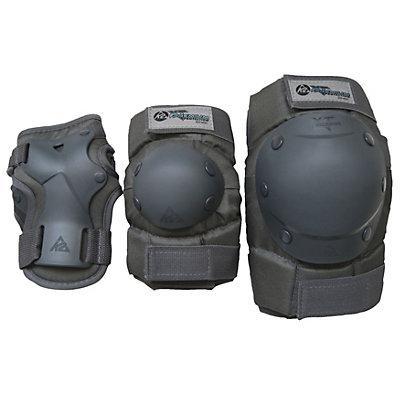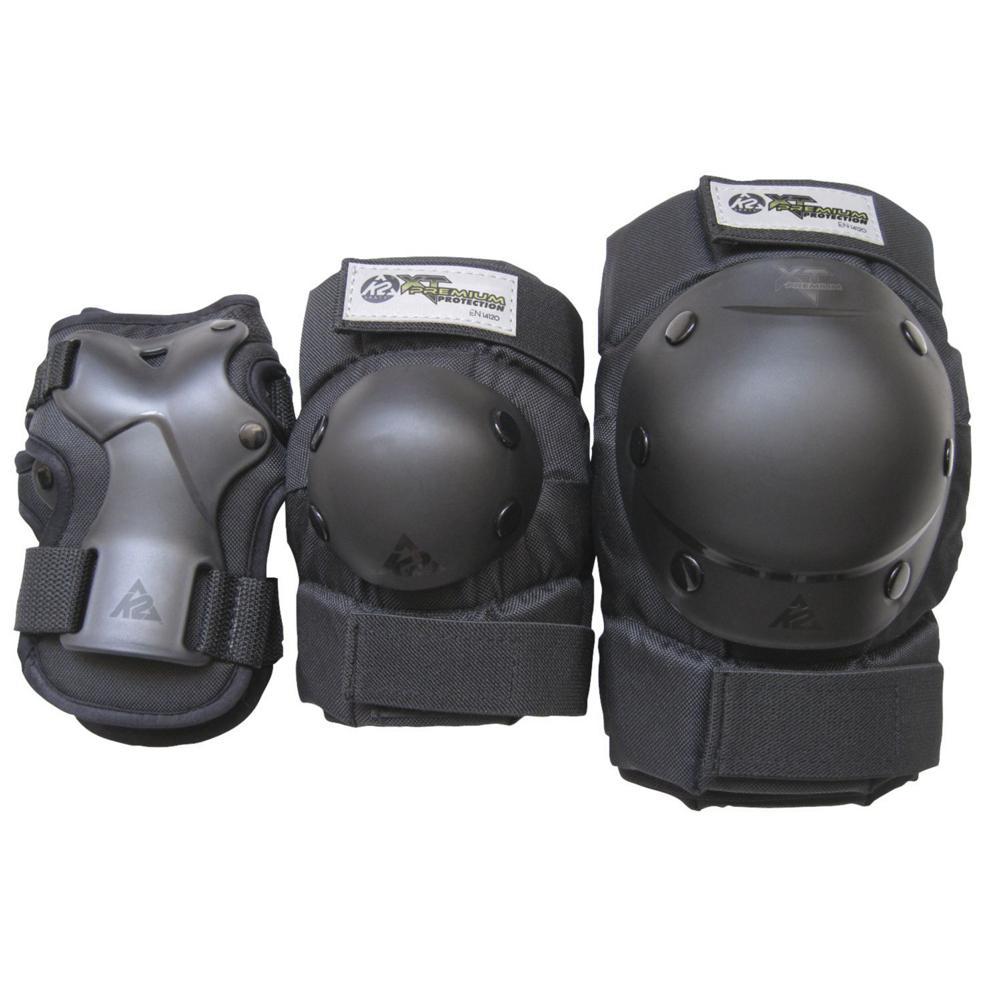The first image is the image on the left, the second image is the image on the right. Assess this claim about the two images: "One image shows more than three individual items of protective gear.". Correct or not? Answer yes or no. No. The first image is the image on the left, the second image is the image on the right. Assess this claim about the two images: "There are at least two sets of pads in the left image.". Correct or not? Answer yes or no. No. 